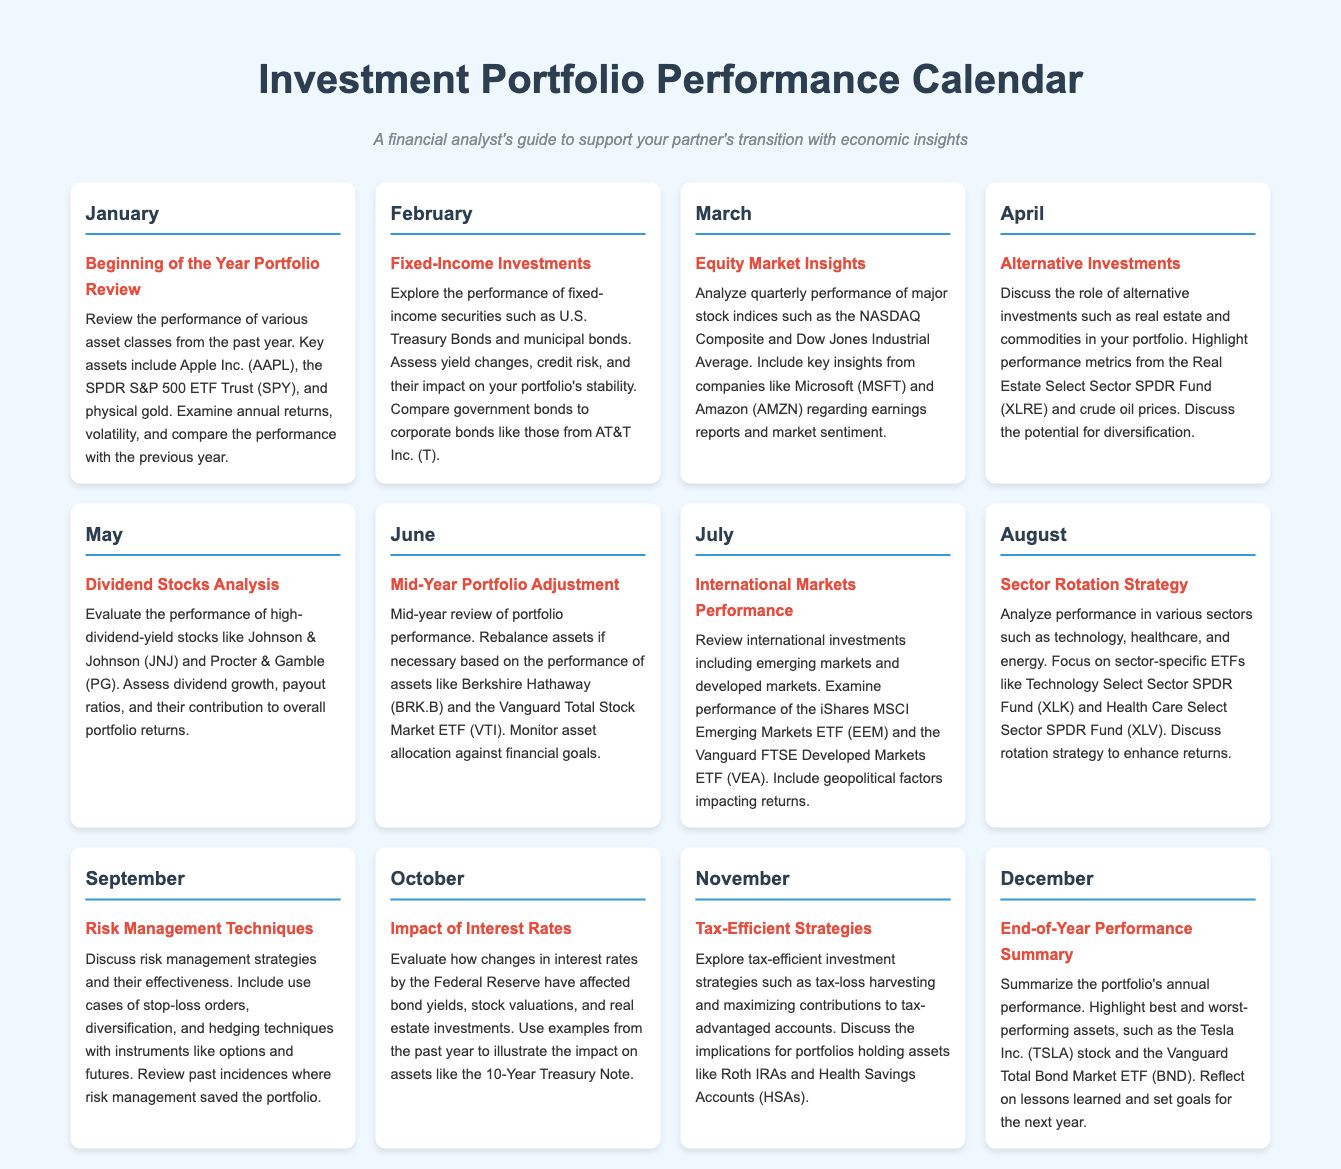what is the title of the document? The title can be found at the top of the rendered document, which describes the content it covers.
Answer: Investment Portfolio Performance Calendar what asset did the February section focus on? The February section highlights fixed-income securities, which include U.S. Treasury Bonds and municipal bonds.
Answer: Fixed-Income Securities which company's stock is mentioned in the May section? The May section evaluates high-dividend-yield stocks and lists specific companies, including the one in question.
Answer: Johnson & Johnson which month discusses sector rotation strategy? The month dedicated to analyzing sector-specific performance and strategies within the document is clearly stated.
Answer: August what is a key asset mentioned in the January review? In the January section, several key assets are reviewed, and one notable one is specifically highlighted.
Answer: Apple Inc. (AAPL) how is the portfolio performance reviewed in June? The June section mentions a specific type of portfolio activity that takes place mid-year to assess investments.
Answer: Mid-Year Portfolio Adjustment what performance metrics are mentioned in April for alternative investments? The April section discusses performance metrics and gives examples of specific assets related to it.
Answer: Real Estate Select Sector SPDR Fund (XLRE) which ETF is highlighted in the July section? The July section includes information on specific international investments, featuring a particular exchange-traded fund.
Answer: iShares MSCI Emerging Markets ETF (EEM) 